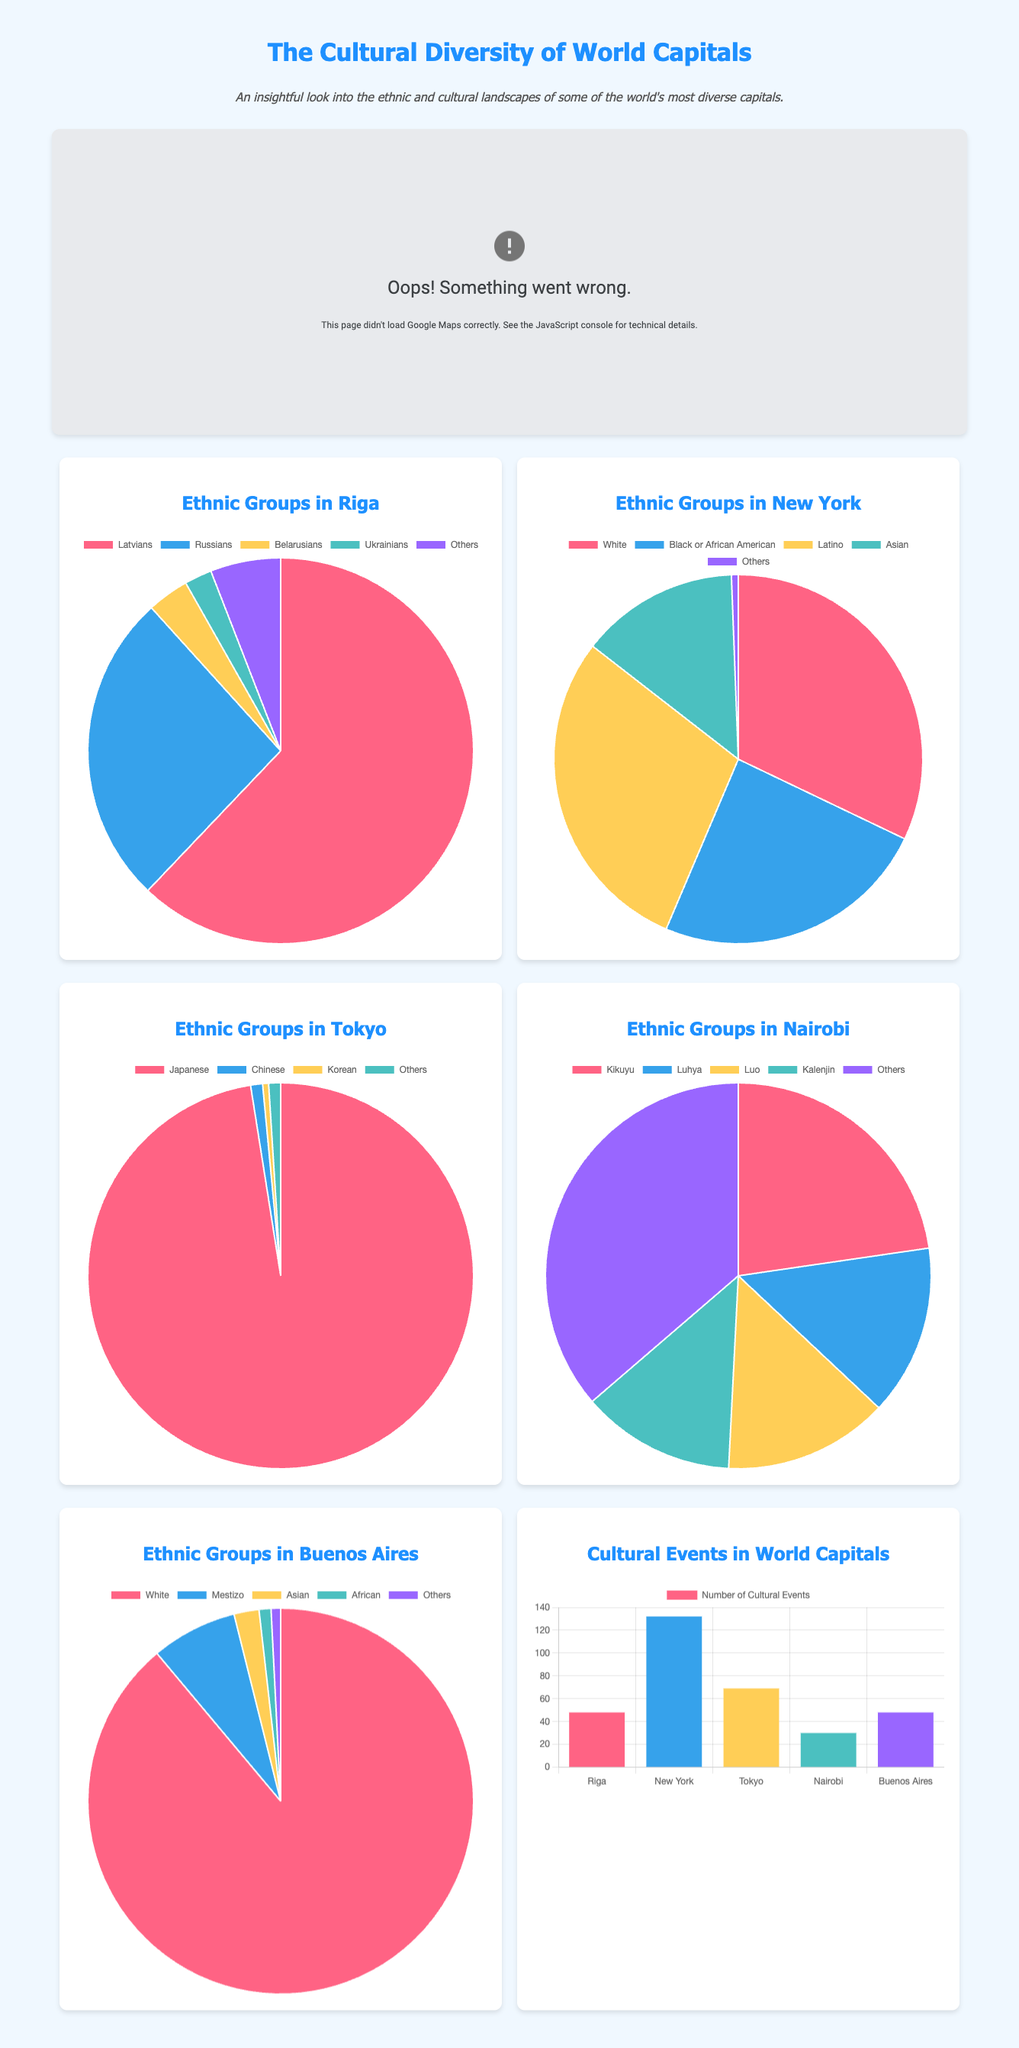What is the percentage of Latvians in Riga? The ethnic group of Latvians in Riga is represented as 62.1% in the pie chart.
Answer: 62.1% How many cultural events are there in New York? The bar graph shows that New York has a total of 132 cultural events per year.
Answer: 132 Which city has the highest percentage of its population as Japanese? The pie chart for Tokyo indicates that 97.5% of the population is Japanese.
Answer: Tokyo What is the combined percentage of Kikuyu and Luhya in Nairobi? The percentages for Kikuyu and Luhya are 22.7% and 14.3% respectively, summing them gives 37%.
Answer: 37% How many ethnic groups are represented in the Buenos Aires pie chart? The pie chart for Buenos Aires includes five ethnic groups: White, Mestizo, Asian, African, and Others.
Answer: Five Which capital has the least number of cultural events? The bar graph indicates that Nairobi has the least number of cultural events at 30.
Answer: Nairobi What is the total number of ethnic groups shown in the charts? There are five ethnic groups listed for each of the five cities, resulting in a total of 25 ethnic group representations.
Answer: Five Which capital has the smallest slice for 'Others' in its ethnic chart? The ethnic group 'Others' in Tokyo has the smallest representation at 1%.
Answer: Tokyo What color represents the African American demographic in New York? In the pie chart for New York, the Black or African American demographic is represented by the color black.
Answer: Black 